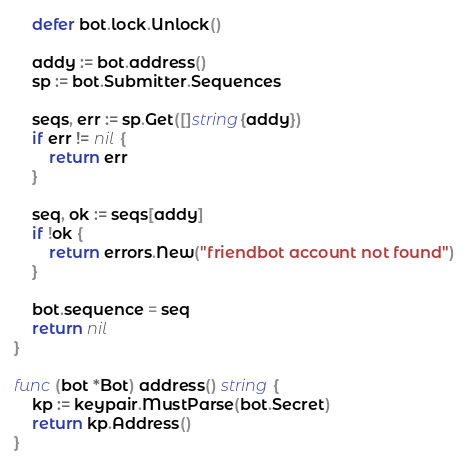Convert code to text. <code><loc_0><loc_0><loc_500><loc_500><_Go_>	defer bot.lock.Unlock()

	addy := bot.address()
	sp := bot.Submitter.Sequences

	seqs, err := sp.Get([]string{addy})
	if err != nil {
		return err
	}

	seq, ok := seqs[addy]
	if !ok {
		return errors.New("friendbot account not found")
	}

	bot.sequence = seq
	return nil
}

func (bot *Bot) address() string {
	kp := keypair.MustParse(bot.Secret)
	return kp.Address()
}
</code> 